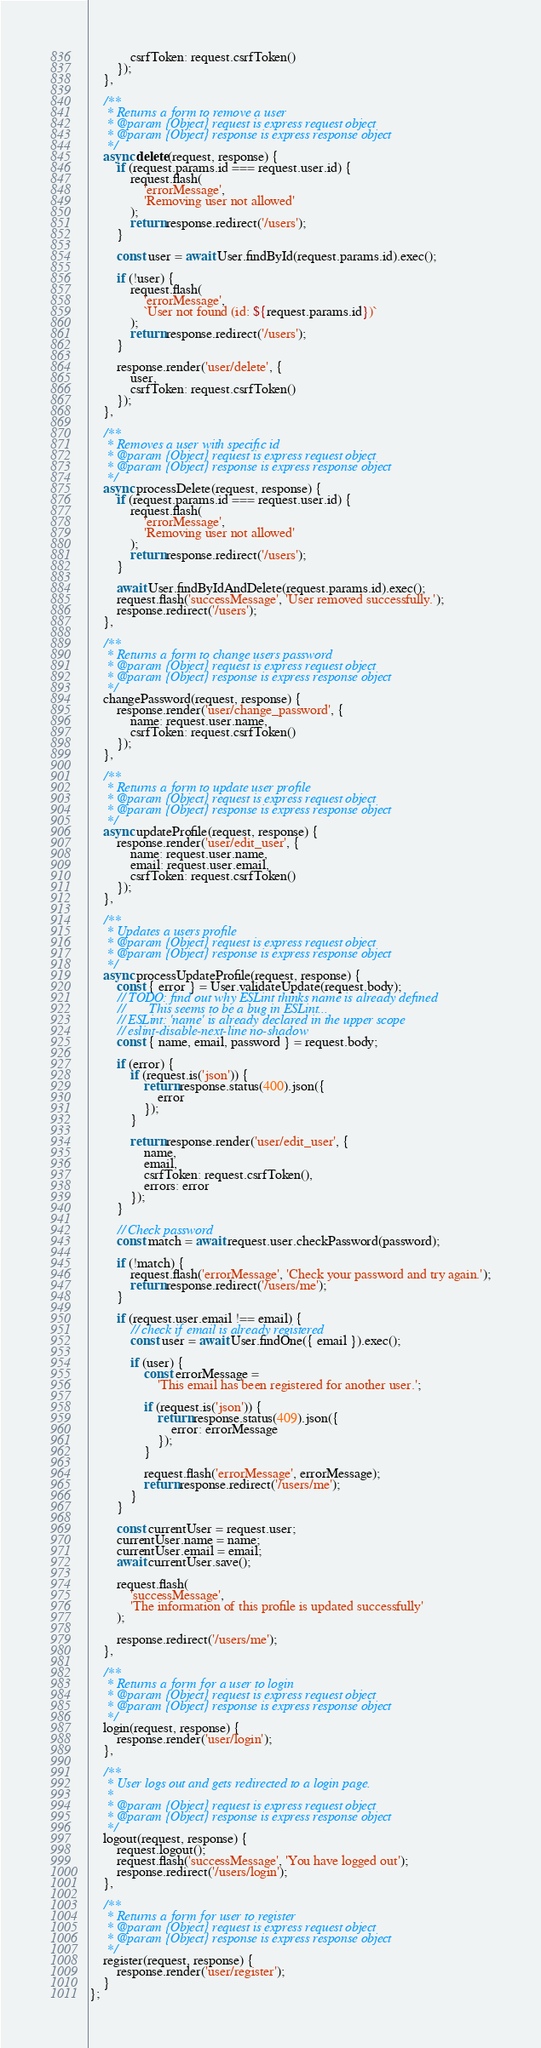<code> <loc_0><loc_0><loc_500><loc_500><_JavaScript_>            csrfToken: request.csrfToken()
        });
    },

    /**
     * Returns a form to remove a user
     * @param {Object} request is express request object
     * @param {Object} response is express response object
     */
    async delete(request, response) {
        if (request.params.id === request.user.id) {
            request.flash(
                'errorMessage',
                'Removing user not allowed'
            );
            return response.redirect('/users');
        }

        const user = await User.findById(request.params.id).exec();

        if (!user) {
            request.flash(
                'errorMessage',
                `User not found (id: ${request.params.id})`
            );
            return response.redirect('/users');
        }

        response.render('user/delete', {
            user,
            csrfToken: request.csrfToken()
        });
    },

    /**
     * Removes a user with specific id
     * @param {Object} request is express request object
     * @param {Object} response is express response object
     */
    async processDelete(request, response) {
        if (request.params.id === request.user.id) {
            request.flash(
                'errorMessage',
                'Removing user not allowed'
            );
            return response.redirect('/users');
        }

        await User.findByIdAndDelete(request.params.id).exec();
        request.flash('successMessage', 'User removed successfully.');
        response.redirect('/users');
    },

    /**
     * Returns a form to change users password
     * @param {Object} request is express request object
     * @param {Object} response is express response object
     */
    changePassword(request, response) {
        response.render('user/change_password', {
            name: request.user.name,
            csrfToken: request.csrfToken()
        });
    },

    /**
     * Returns a form to update user profile
     * @param {Object} request is express request object
     * @param {Object} response is express response object
     */
    async updateProfile(request, response) {
        response.render('user/edit_user', {
            name: request.user.name,
            email: request.user.email,
            csrfToken: request.csrfToken()
        });
    },

    /**
     * Updates a users profile
     * @param {Object} request is express request object
     * @param {Object} response is express response object
     */
    async processUpdateProfile(request, response) {
        const { error } = User.validateUpdate(request.body);
        // TODO: find out why ESLint thinks name is already defined
        //       This seems to be a bug in ESLint...
        // ESLint: 'name' is already declared in the upper scope
        // eslint-disable-next-line no-shadow
        const { name, email, password } = request.body;

        if (error) {
            if (request.is('json')) {
                return response.status(400).json({
                    error
                });
            }

            return response.render('user/edit_user', {
                name,
                email,
                csrfToken: request.csrfToken(),
                errors: error
            });
        }

        // Check password
        const match = await request.user.checkPassword(password);

        if (!match) {
            request.flash('errorMessage', 'Check your password and try again.');
            return response.redirect('/users/me');
        }

        if (request.user.email !== email) {
            // check if email is already registered
            const user = await User.findOne({ email }).exec();

            if (user) {
                const errorMessage =
                    'This email has been registered for another user.';

                if (request.is('json')) {
                    return response.status(409).json({
                        error: errorMessage
                    });
                }

                request.flash('errorMessage', errorMessage);
                return response.redirect('/users/me');
            }
        }

        const currentUser = request.user;
        currentUser.name = name;
        currentUser.email = email;
        await currentUser.save();

        request.flash(
            'successMessage',
            'The information of this profile is updated successfully'
        );

        response.redirect('/users/me');
    },

    /**
     * Returns a form for a user to login
     * @param {Object} request is express request object
     * @param {Object} response is express response object
     */
    login(request, response) {
        response.render('user/login');
    },

    /**
     * User logs out and gets redirected to a login page.
     *
     * @param {Object} request is express request object
     * @param {Object} response is express response object
     */
    logout(request, response) {
        request.logout();
        request.flash('successMessage', 'You have logged out');
        response.redirect('/users/login');
    },

    /**
     * Returns a form for user to register
     * @param {Object} request is express request object
     * @param {Object} response is express response object
     */
    register(request, response) {
        response.render('user/register');
    }
};
</code> 